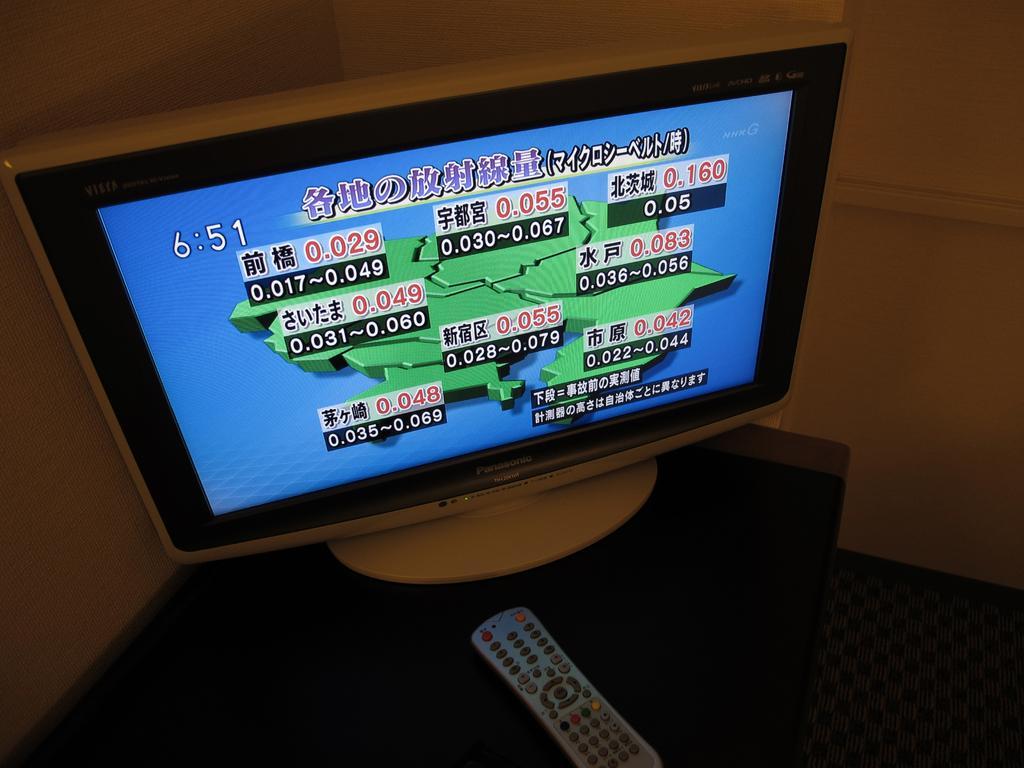Please provide a concise description of this image. In this picture I can see a television and a remote on the table, there is carpet, and in the background there is a wall. 